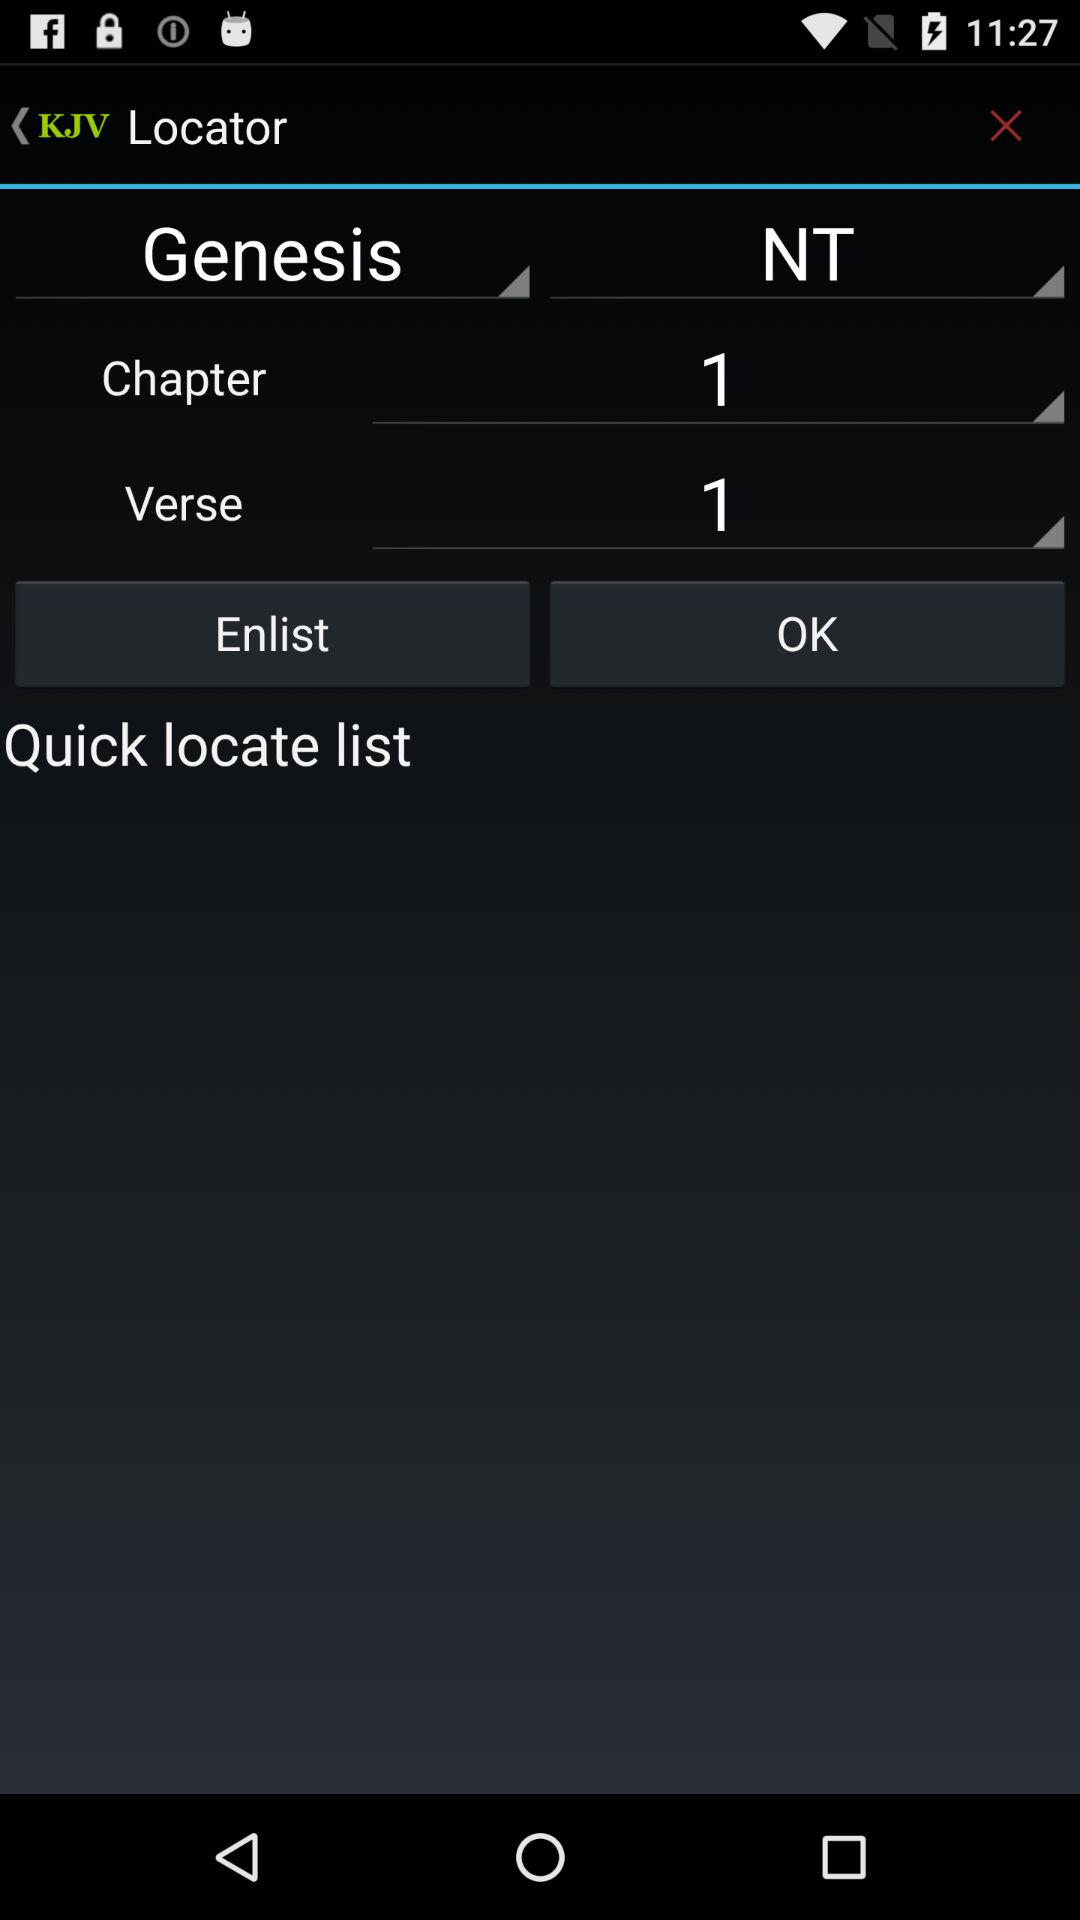What is the name of the application? The name of the application is "Bible KJV". 